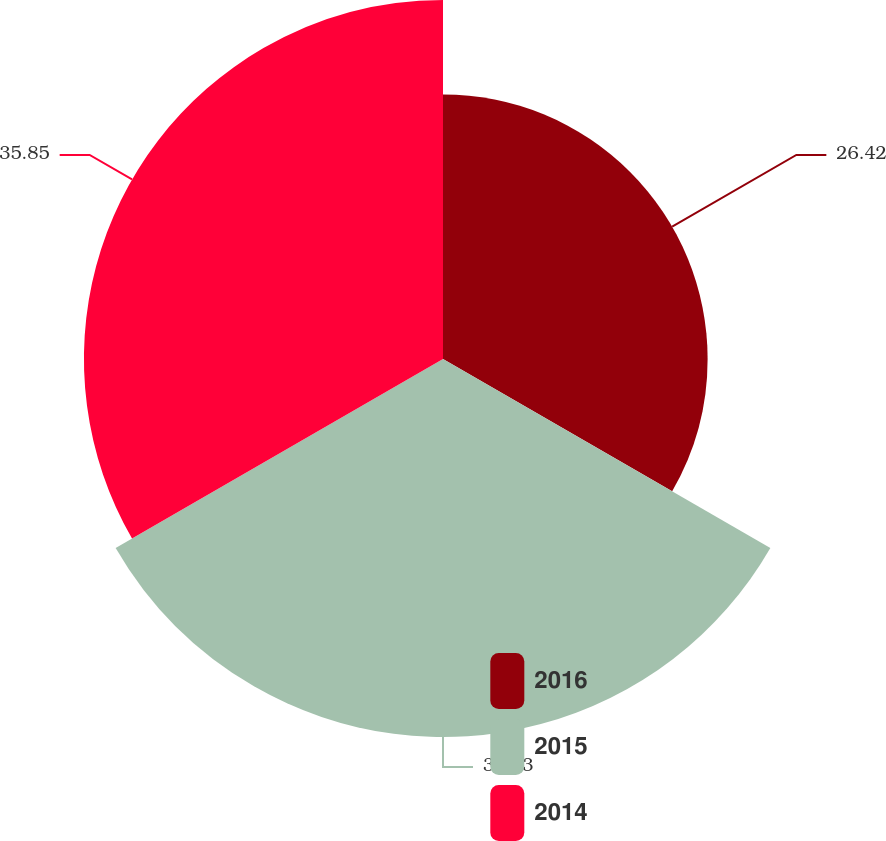<chart> <loc_0><loc_0><loc_500><loc_500><pie_chart><fcel>2016<fcel>2015<fcel>2014<nl><fcel>26.42%<fcel>37.74%<fcel>35.85%<nl></chart> 